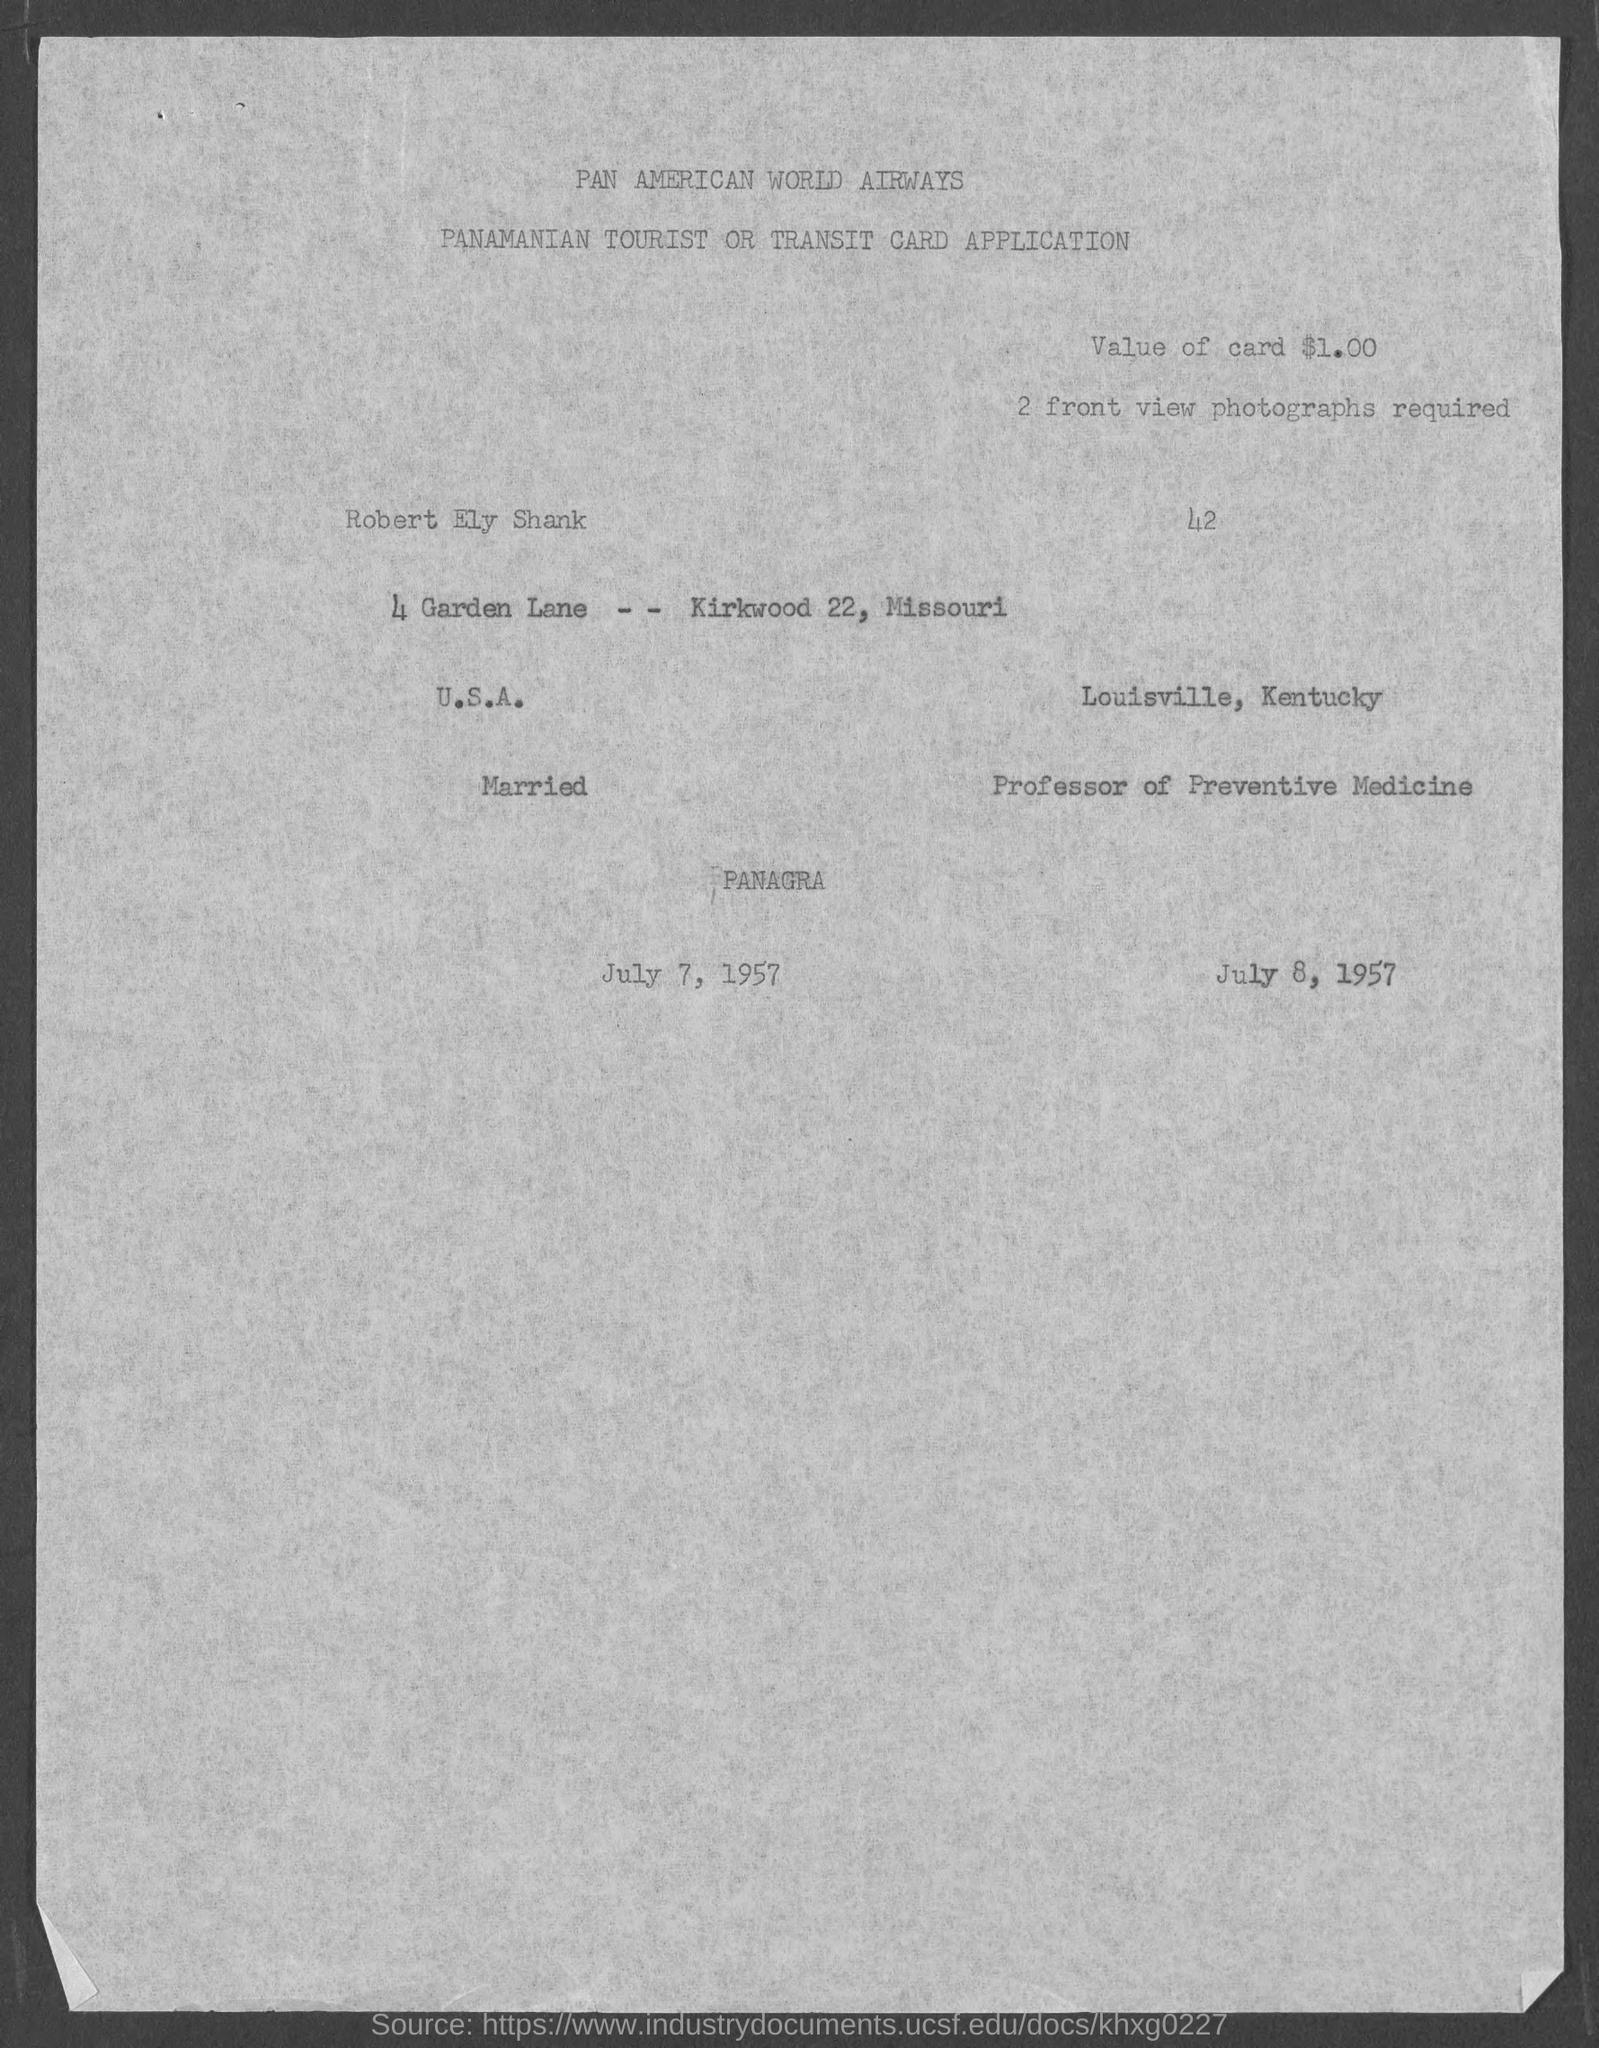What is the value of card?
Ensure brevity in your answer.  $1.00. 